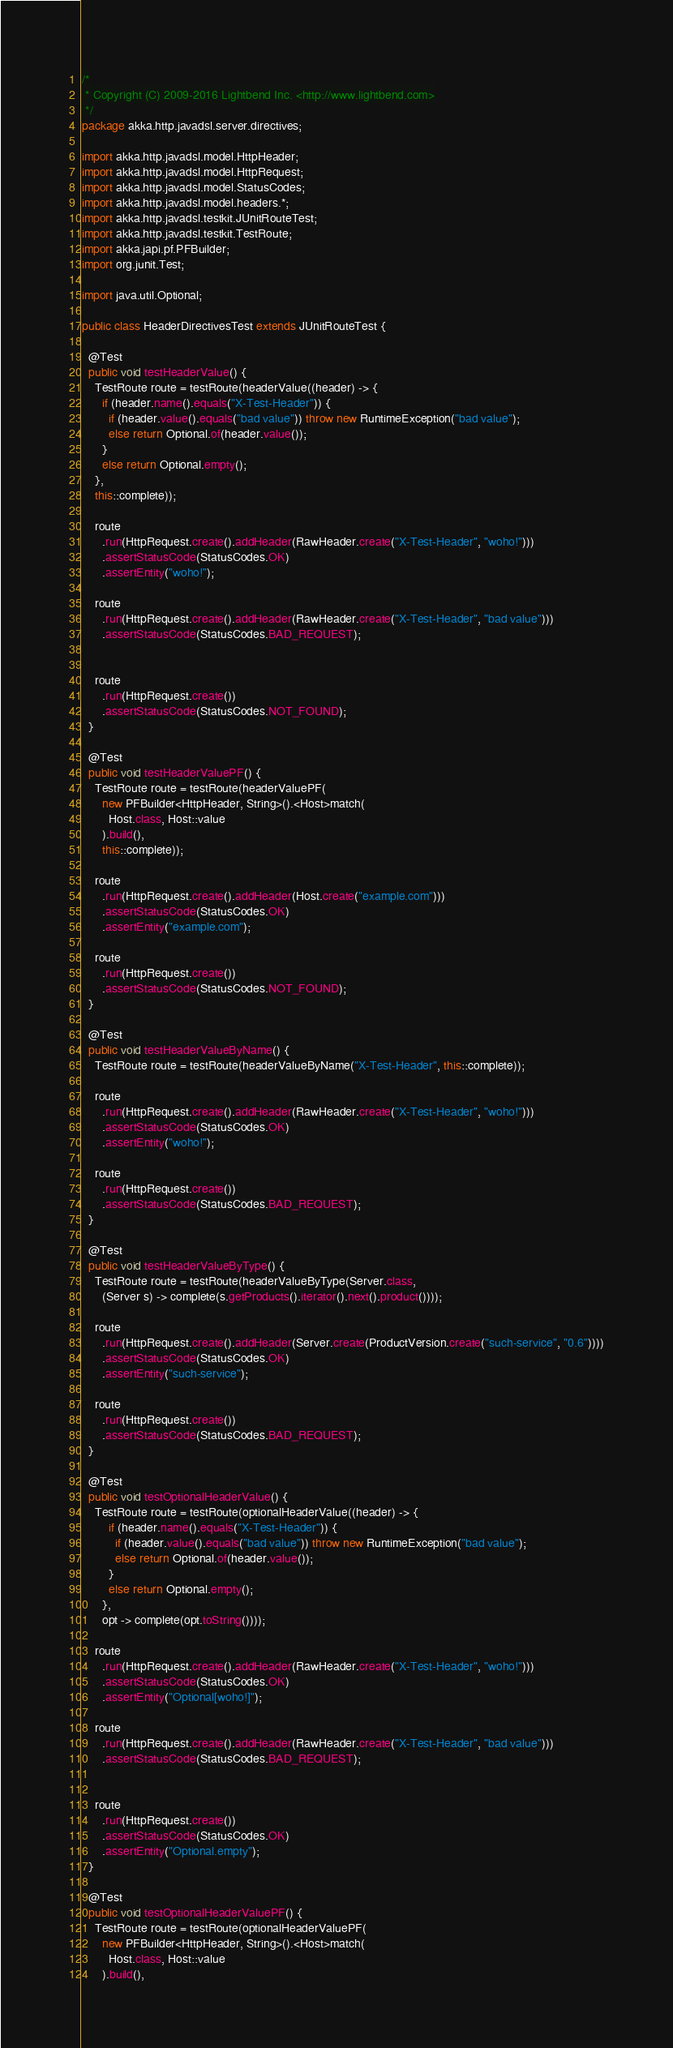<code> <loc_0><loc_0><loc_500><loc_500><_Java_>/*
 * Copyright (C) 2009-2016 Lightbend Inc. <http://www.lightbend.com>
 */
package akka.http.javadsl.server.directives;

import akka.http.javadsl.model.HttpHeader;
import akka.http.javadsl.model.HttpRequest;
import akka.http.javadsl.model.StatusCodes;
import akka.http.javadsl.model.headers.*;
import akka.http.javadsl.testkit.JUnitRouteTest;
import akka.http.javadsl.testkit.TestRoute;
import akka.japi.pf.PFBuilder;
import org.junit.Test;

import java.util.Optional;

public class HeaderDirectivesTest extends JUnitRouteTest {

  @Test
  public void testHeaderValue() {
    TestRoute route = testRoute(headerValue((header) -> {
      if (header.name().equals("X-Test-Header")) {
        if (header.value().equals("bad value")) throw new RuntimeException("bad value");
        else return Optional.of(header.value());
      }
      else return Optional.empty();
    },
    this::complete));

    route
      .run(HttpRequest.create().addHeader(RawHeader.create("X-Test-Header", "woho!")))
      .assertStatusCode(StatusCodes.OK)
      .assertEntity("woho!");

    route
      .run(HttpRequest.create().addHeader(RawHeader.create("X-Test-Header", "bad value")))
      .assertStatusCode(StatusCodes.BAD_REQUEST);


    route
      .run(HttpRequest.create())
      .assertStatusCode(StatusCodes.NOT_FOUND);
  }

  @Test
  public void testHeaderValuePF() {
    TestRoute route = testRoute(headerValuePF(
      new PFBuilder<HttpHeader, String>().<Host>match(
        Host.class, Host::value
      ).build(),
      this::complete));

    route
      .run(HttpRequest.create().addHeader(Host.create("example.com")))
      .assertStatusCode(StatusCodes.OK)
      .assertEntity("example.com");

    route
      .run(HttpRequest.create())
      .assertStatusCode(StatusCodes.NOT_FOUND);
  }

  @Test
  public void testHeaderValueByName() {
    TestRoute route = testRoute(headerValueByName("X-Test-Header", this::complete));

    route
      .run(HttpRequest.create().addHeader(RawHeader.create("X-Test-Header", "woho!")))
      .assertStatusCode(StatusCodes.OK)
      .assertEntity("woho!");

    route
      .run(HttpRequest.create())
      .assertStatusCode(StatusCodes.BAD_REQUEST);
  }

  @Test
  public void testHeaderValueByType() {
    TestRoute route = testRoute(headerValueByType(Server.class,
      (Server s) -> complete(s.getProducts().iterator().next().product())));

    route
      .run(HttpRequest.create().addHeader(Server.create(ProductVersion.create("such-service", "0.6"))))
      .assertStatusCode(StatusCodes.OK)
      .assertEntity("such-service");

    route
      .run(HttpRequest.create())
      .assertStatusCode(StatusCodes.BAD_REQUEST);
  }

  @Test
  public void testOptionalHeaderValue() {
    TestRoute route = testRoute(optionalHeaderValue((header) -> {
        if (header.name().equals("X-Test-Header")) {
          if (header.value().equals("bad value")) throw new RuntimeException("bad value");
          else return Optional.of(header.value());
        }
        else return Optional.empty();
      },
      opt -> complete(opt.toString())));

    route
      .run(HttpRequest.create().addHeader(RawHeader.create("X-Test-Header", "woho!")))
      .assertStatusCode(StatusCodes.OK)
      .assertEntity("Optional[woho!]");

    route
      .run(HttpRequest.create().addHeader(RawHeader.create("X-Test-Header", "bad value")))
      .assertStatusCode(StatusCodes.BAD_REQUEST);


    route
      .run(HttpRequest.create())
      .assertStatusCode(StatusCodes.OK)
      .assertEntity("Optional.empty");
  }

  @Test
  public void testOptionalHeaderValuePF() {
    TestRoute route = testRoute(optionalHeaderValuePF(
      new PFBuilder<HttpHeader, String>().<Host>match(
        Host.class, Host::value
      ).build(),</code> 